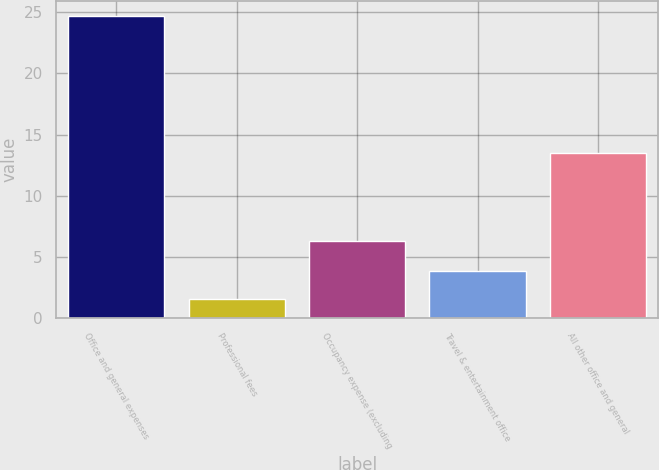Convert chart. <chart><loc_0><loc_0><loc_500><loc_500><bar_chart><fcel>Office and general expenses<fcel>Professional fees<fcel>Occupancy expense (excluding<fcel>Travel & entertainment office<fcel>All other office and general<nl><fcel>24.7<fcel>1.6<fcel>6.3<fcel>3.91<fcel>13.5<nl></chart> 